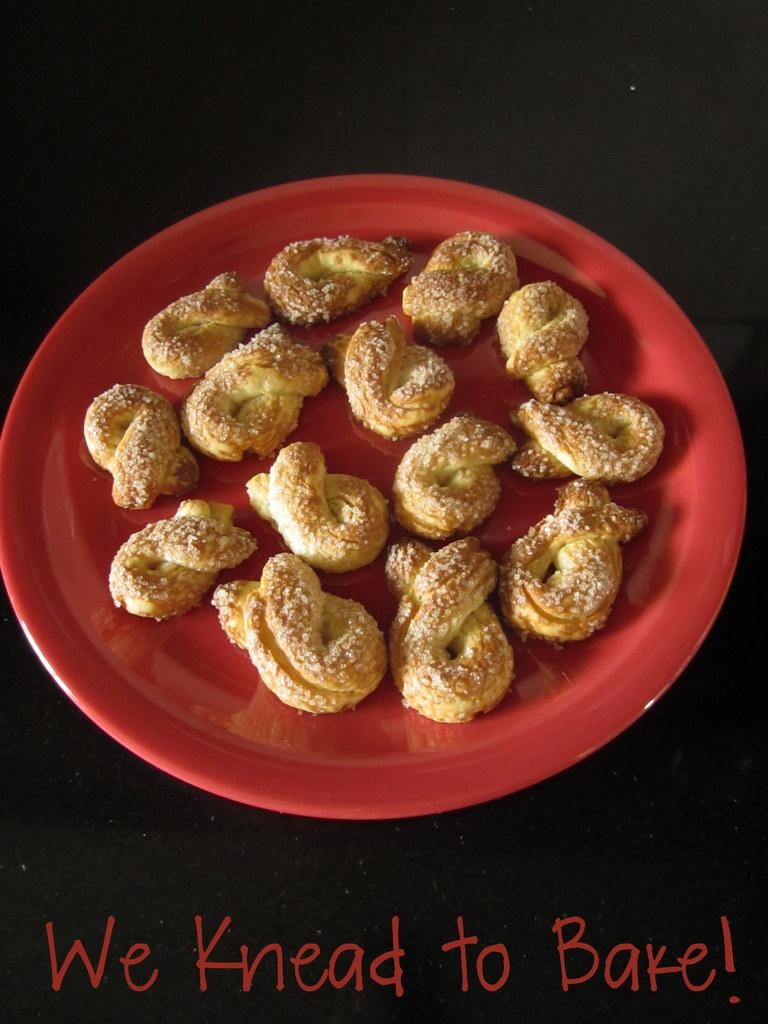What is the main subject of the image? There is a food item on a plate in the image. Can you describe the background of the image? The background of the image is dark. What type of debt is being discussed in the image? There is no mention of debt in the image; it features a food item on a plate with a dark background. What color is the ink used to write on the paper in the image? There is no paper or writing present in the image; it only shows a food item on a plate with a dark background. 